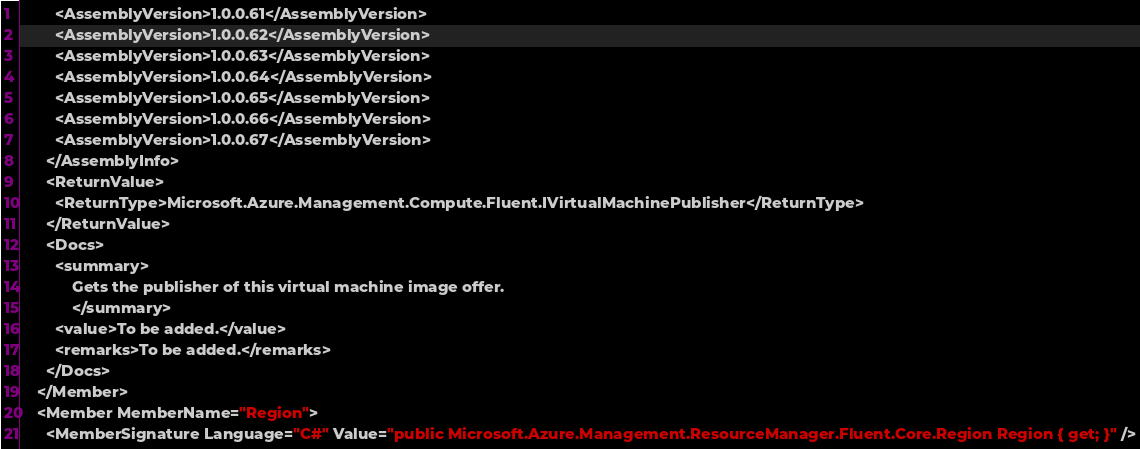<code> <loc_0><loc_0><loc_500><loc_500><_XML_>        <AssemblyVersion>1.0.0.61</AssemblyVersion>
        <AssemblyVersion>1.0.0.62</AssemblyVersion>
        <AssemblyVersion>1.0.0.63</AssemblyVersion>
        <AssemblyVersion>1.0.0.64</AssemblyVersion>
        <AssemblyVersion>1.0.0.65</AssemblyVersion>
        <AssemblyVersion>1.0.0.66</AssemblyVersion>
        <AssemblyVersion>1.0.0.67</AssemblyVersion>
      </AssemblyInfo>
      <ReturnValue>
        <ReturnType>Microsoft.Azure.Management.Compute.Fluent.IVirtualMachinePublisher</ReturnType>
      </ReturnValue>
      <Docs>
        <summary>
            Gets the publisher of this virtual machine image offer.
            </summary>
        <value>To be added.</value>
        <remarks>To be added.</remarks>
      </Docs>
    </Member>
    <Member MemberName="Region">
      <MemberSignature Language="C#" Value="public Microsoft.Azure.Management.ResourceManager.Fluent.Core.Region Region { get; }" /></code> 